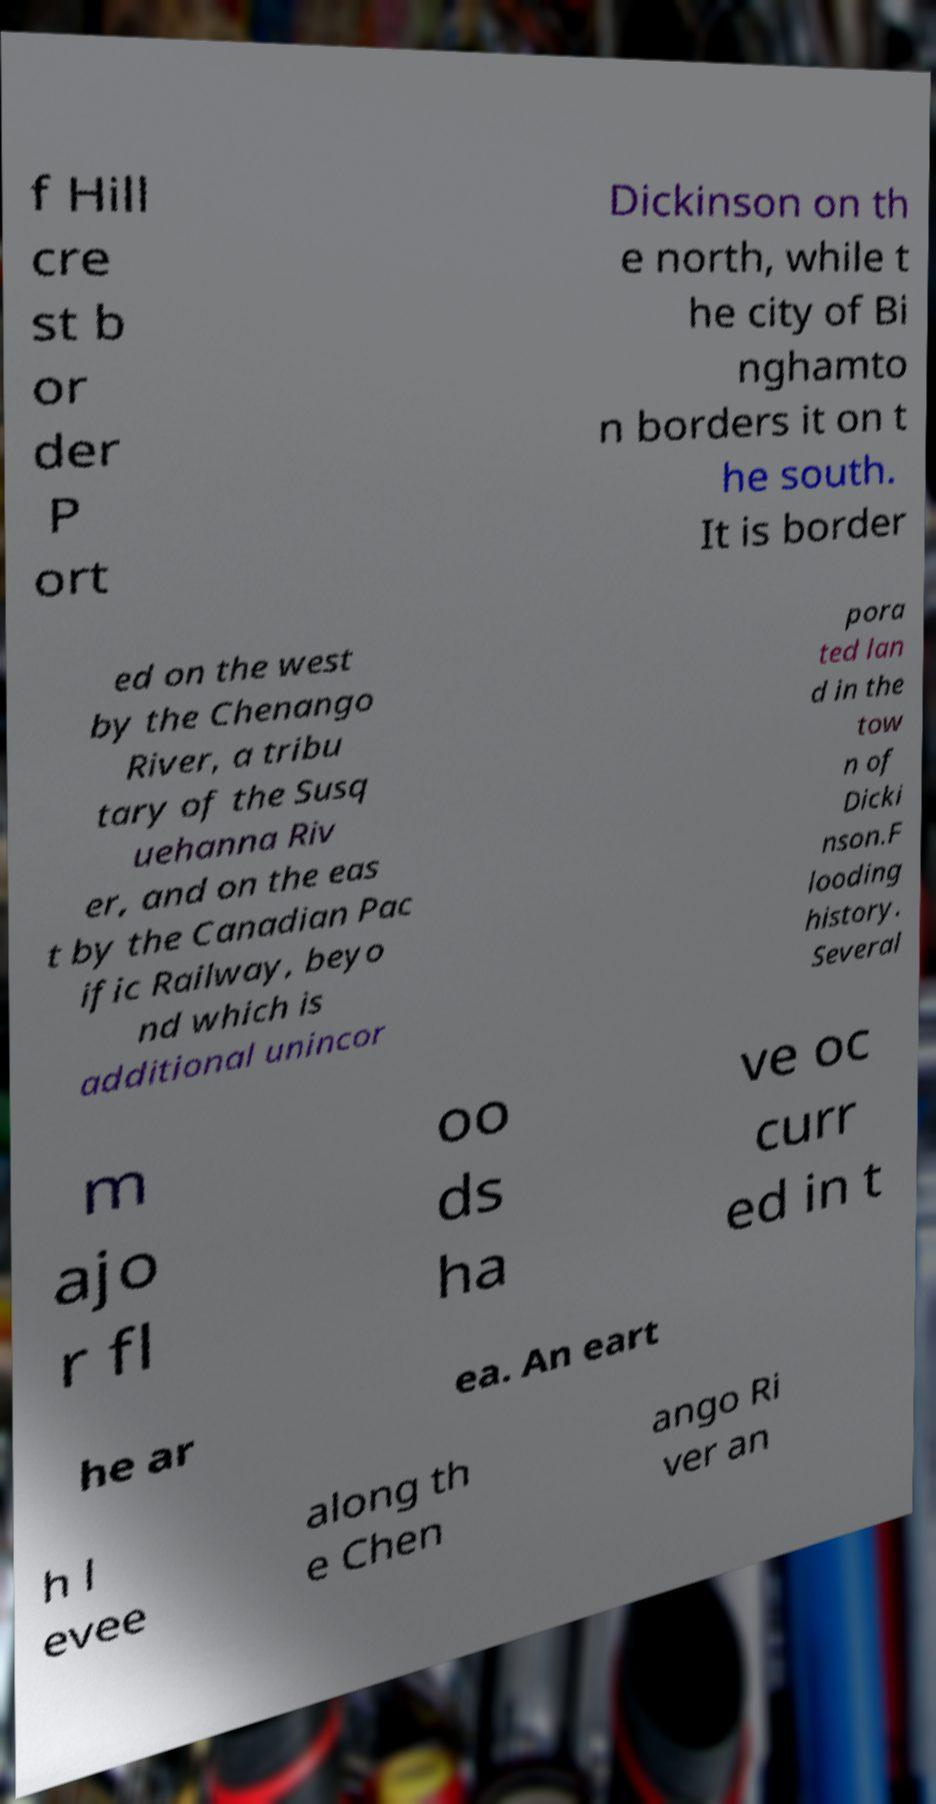Could you assist in decoding the text presented in this image and type it out clearly? f Hill cre st b or der P ort Dickinson on th e north, while t he city of Bi nghamto n borders it on t he south. It is border ed on the west by the Chenango River, a tribu tary of the Susq uehanna Riv er, and on the eas t by the Canadian Pac ific Railway, beyo nd which is additional unincor pora ted lan d in the tow n of Dicki nson.F looding history. Several m ajo r fl oo ds ha ve oc curr ed in t he ar ea. An eart h l evee along th e Chen ango Ri ver an 